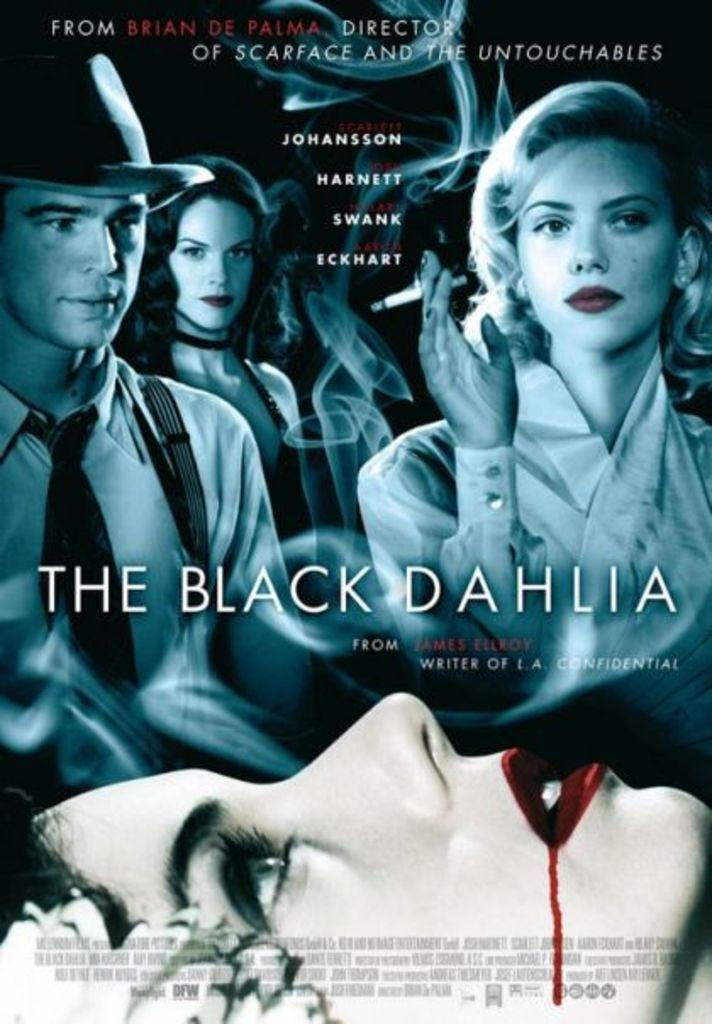<image>
Offer a succinct explanation of the picture presented. The cover of The Black Dahlie features a woman bleeding from the mouth. 